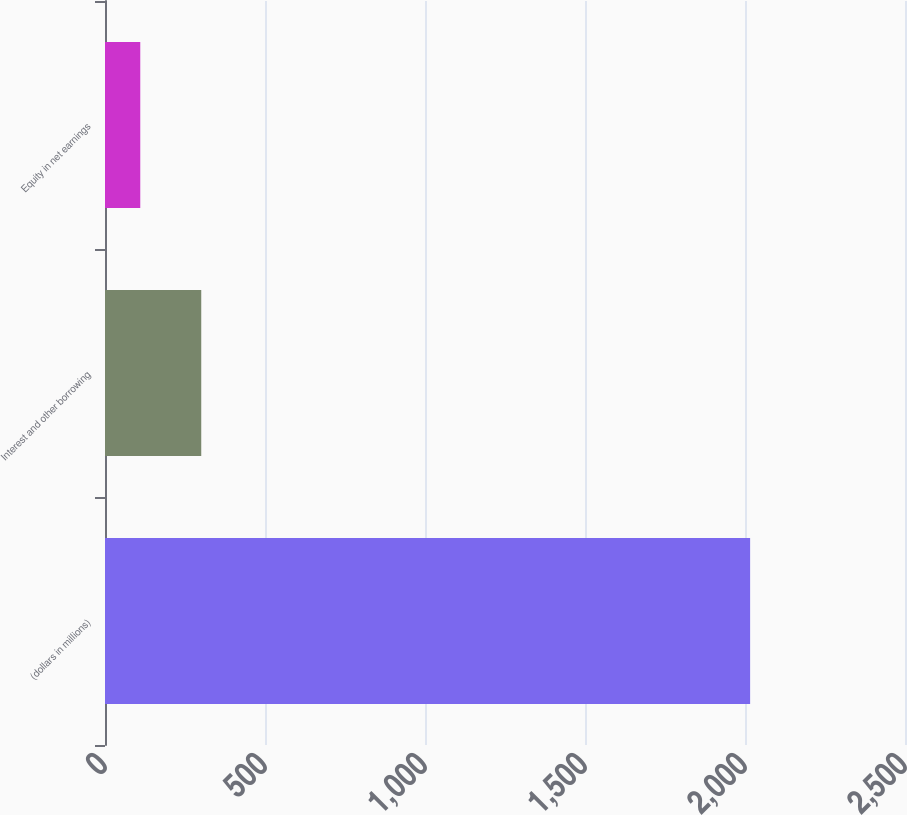Convert chart. <chart><loc_0><loc_0><loc_500><loc_500><bar_chart><fcel>(dollars in millions)<fcel>Interest and other borrowing<fcel>Equity in net earnings<nl><fcel>2016<fcel>300.78<fcel>110.2<nl></chart> 